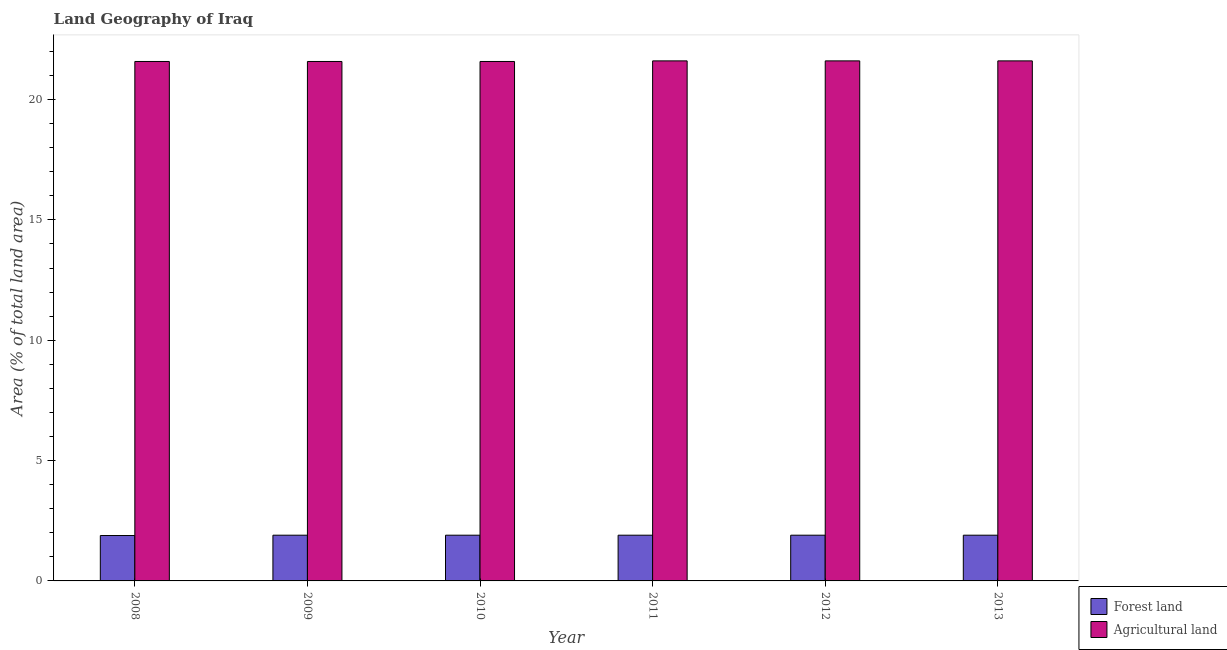Are the number of bars per tick equal to the number of legend labels?
Offer a very short reply. Yes. How many bars are there on the 5th tick from the right?
Ensure brevity in your answer.  2. In how many cases, is the number of bars for a given year not equal to the number of legend labels?
Ensure brevity in your answer.  0. What is the percentage of land area under forests in 2011?
Offer a terse response. 1.9. Across all years, what is the maximum percentage of land area under forests?
Make the answer very short. 1.9. Across all years, what is the minimum percentage of land area under forests?
Keep it short and to the point. 1.89. In which year was the percentage of land area under forests maximum?
Your response must be concise. 2009. In which year was the percentage of land area under agriculture minimum?
Your response must be concise. 2008. What is the total percentage of land area under agriculture in the graph?
Your response must be concise. 129.56. What is the difference between the percentage of land area under agriculture in 2008 and that in 2011?
Keep it short and to the point. -0.03. What is the average percentage of land area under forests per year?
Keep it short and to the point. 1.9. In how many years, is the percentage of land area under forests greater than 13 %?
Provide a short and direct response. 0. Is the percentage of land area under agriculture in 2012 less than that in 2013?
Provide a succinct answer. No. Is the difference between the percentage of land area under forests in 2008 and 2013 greater than the difference between the percentage of land area under agriculture in 2008 and 2013?
Offer a very short reply. No. What is the difference between the highest and the lowest percentage of land area under forests?
Provide a short and direct response. 0.01. In how many years, is the percentage of land area under forests greater than the average percentage of land area under forests taken over all years?
Keep it short and to the point. 5. What does the 2nd bar from the left in 2009 represents?
Make the answer very short. Agricultural land. What does the 1st bar from the right in 2011 represents?
Your answer should be very brief. Agricultural land. Are all the bars in the graph horizontal?
Your response must be concise. No. What is the difference between two consecutive major ticks on the Y-axis?
Your response must be concise. 5. Are the values on the major ticks of Y-axis written in scientific E-notation?
Keep it short and to the point. No. Does the graph contain any zero values?
Your answer should be compact. No. Does the graph contain grids?
Keep it short and to the point. No. What is the title of the graph?
Your answer should be compact. Land Geography of Iraq. What is the label or title of the Y-axis?
Keep it short and to the point. Area (% of total land area). What is the Area (% of total land area) of Forest land in 2008?
Offer a very short reply. 1.89. What is the Area (% of total land area) in Agricultural land in 2008?
Your answer should be very brief. 21.58. What is the Area (% of total land area) in Forest land in 2009?
Your answer should be very brief. 1.9. What is the Area (% of total land area) in Agricultural land in 2009?
Give a very brief answer. 21.58. What is the Area (% of total land area) of Forest land in 2010?
Provide a short and direct response. 1.9. What is the Area (% of total land area) in Agricultural land in 2010?
Provide a succinct answer. 21.58. What is the Area (% of total land area) in Forest land in 2011?
Keep it short and to the point. 1.9. What is the Area (% of total land area) in Agricultural land in 2011?
Provide a succinct answer. 21.61. What is the Area (% of total land area) in Forest land in 2012?
Provide a short and direct response. 1.9. What is the Area (% of total land area) in Agricultural land in 2012?
Your response must be concise. 21.61. What is the Area (% of total land area) in Forest land in 2013?
Give a very brief answer. 1.9. What is the Area (% of total land area) in Agricultural land in 2013?
Make the answer very short. 21.61. Across all years, what is the maximum Area (% of total land area) of Forest land?
Give a very brief answer. 1.9. Across all years, what is the maximum Area (% of total land area) in Agricultural land?
Your response must be concise. 21.61. Across all years, what is the minimum Area (% of total land area) of Forest land?
Your answer should be compact. 1.89. Across all years, what is the minimum Area (% of total land area) of Agricultural land?
Give a very brief answer. 21.58. What is the total Area (% of total land area) of Forest land in the graph?
Provide a short and direct response. 11.38. What is the total Area (% of total land area) of Agricultural land in the graph?
Offer a very short reply. 129.56. What is the difference between the Area (% of total land area) in Forest land in 2008 and that in 2009?
Provide a short and direct response. -0.01. What is the difference between the Area (% of total land area) in Forest land in 2008 and that in 2010?
Your response must be concise. -0.01. What is the difference between the Area (% of total land area) in Forest land in 2008 and that in 2011?
Your answer should be very brief. -0.01. What is the difference between the Area (% of total land area) in Agricultural land in 2008 and that in 2011?
Provide a succinct answer. -0.03. What is the difference between the Area (% of total land area) in Forest land in 2008 and that in 2012?
Provide a succinct answer. -0.01. What is the difference between the Area (% of total land area) in Agricultural land in 2008 and that in 2012?
Keep it short and to the point. -0.03. What is the difference between the Area (% of total land area) in Forest land in 2008 and that in 2013?
Make the answer very short. -0.01. What is the difference between the Area (% of total land area) in Agricultural land in 2008 and that in 2013?
Offer a terse response. -0.03. What is the difference between the Area (% of total land area) in Forest land in 2009 and that in 2011?
Provide a short and direct response. 0. What is the difference between the Area (% of total land area) of Agricultural land in 2009 and that in 2011?
Offer a very short reply. -0.03. What is the difference between the Area (% of total land area) of Forest land in 2009 and that in 2012?
Ensure brevity in your answer.  0. What is the difference between the Area (% of total land area) in Agricultural land in 2009 and that in 2012?
Your answer should be compact. -0.03. What is the difference between the Area (% of total land area) of Forest land in 2009 and that in 2013?
Provide a short and direct response. 0. What is the difference between the Area (% of total land area) in Agricultural land in 2009 and that in 2013?
Your answer should be very brief. -0.03. What is the difference between the Area (% of total land area) in Agricultural land in 2010 and that in 2011?
Keep it short and to the point. -0.03. What is the difference between the Area (% of total land area) of Agricultural land in 2010 and that in 2012?
Ensure brevity in your answer.  -0.03. What is the difference between the Area (% of total land area) in Forest land in 2010 and that in 2013?
Give a very brief answer. 0. What is the difference between the Area (% of total land area) of Agricultural land in 2010 and that in 2013?
Offer a terse response. -0.03. What is the difference between the Area (% of total land area) in Forest land in 2011 and that in 2012?
Your answer should be compact. 0. What is the difference between the Area (% of total land area) in Agricultural land in 2011 and that in 2012?
Your answer should be compact. 0. What is the difference between the Area (% of total land area) in Forest land in 2011 and that in 2013?
Offer a very short reply. 0. What is the difference between the Area (% of total land area) in Agricultural land in 2011 and that in 2013?
Offer a very short reply. 0. What is the difference between the Area (% of total land area) in Forest land in 2012 and that in 2013?
Offer a terse response. 0. What is the difference between the Area (% of total land area) of Forest land in 2008 and the Area (% of total land area) of Agricultural land in 2009?
Offer a very short reply. -19.7. What is the difference between the Area (% of total land area) of Forest land in 2008 and the Area (% of total land area) of Agricultural land in 2010?
Your answer should be very brief. -19.7. What is the difference between the Area (% of total land area) in Forest land in 2008 and the Area (% of total land area) in Agricultural land in 2011?
Your answer should be compact. -19.72. What is the difference between the Area (% of total land area) in Forest land in 2008 and the Area (% of total land area) in Agricultural land in 2012?
Provide a short and direct response. -19.72. What is the difference between the Area (% of total land area) in Forest land in 2008 and the Area (% of total land area) in Agricultural land in 2013?
Ensure brevity in your answer.  -19.72. What is the difference between the Area (% of total land area) of Forest land in 2009 and the Area (% of total land area) of Agricultural land in 2010?
Your response must be concise. -19.68. What is the difference between the Area (% of total land area) of Forest land in 2009 and the Area (% of total land area) of Agricultural land in 2011?
Your answer should be very brief. -19.71. What is the difference between the Area (% of total land area) in Forest land in 2009 and the Area (% of total land area) in Agricultural land in 2012?
Provide a succinct answer. -19.71. What is the difference between the Area (% of total land area) in Forest land in 2009 and the Area (% of total land area) in Agricultural land in 2013?
Offer a very short reply. -19.71. What is the difference between the Area (% of total land area) in Forest land in 2010 and the Area (% of total land area) in Agricultural land in 2011?
Ensure brevity in your answer.  -19.71. What is the difference between the Area (% of total land area) of Forest land in 2010 and the Area (% of total land area) of Agricultural land in 2012?
Your answer should be compact. -19.71. What is the difference between the Area (% of total land area) in Forest land in 2010 and the Area (% of total land area) in Agricultural land in 2013?
Offer a terse response. -19.71. What is the difference between the Area (% of total land area) in Forest land in 2011 and the Area (% of total land area) in Agricultural land in 2012?
Give a very brief answer. -19.71. What is the difference between the Area (% of total land area) in Forest land in 2011 and the Area (% of total land area) in Agricultural land in 2013?
Give a very brief answer. -19.71. What is the difference between the Area (% of total land area) of Forest land in 2012 and the Area (% of total land area) of Agricultural land in 2013?
Keep it short and to the point. -19.71. What is the average Area (% of total land area) in Forest land per year?
Provide a short and direct response. 1.9. What is the average Area (% of total land area) in Agricultural land per year?
Your answer should be very brief. 21.59. In the year 2008, what is the difference between the Area (% of total land area) in Forest land and Area (% of total land area) in Agricultural land?
Provide a short and direct response. -19.7. In the year 2009, what is the difference between the Area (% of total land area) in Forest land and Area (% of total land area) in Agricultural land?
Offer a very short reply. -19.68. In the year 2010, what is the difference between the Area (% of total land area) in Forest land and Area (% of total land area) in Agricultural land?
Provide a short and direct response. -19.68. In the year 2011, what is the difference between the Area (% of total land area) of Forest land and Area (% of total land area) of Agricultural land?
Keep it short and to the point. -19.71. In the year 2012, what is the difference between the Area (% of total land area) in Forest land and Area (% of total land area) in Agricultural land?
Provide a short and direct response. -19.71. In the year 2013, what is the difference between the Area (% of total land area) in Forest land and Area (% of total land area) in Agricultural land?
Ensure brevity in your answer.  -19.71. What is the ratio of the Area (% of total land area) of Agricultural land in 2008 to that in 2009?
Make the answer very short. 1. What is the ratio of the Area (% of total land area) of Forest land in 2008 to that in 2011?
Your answer should be compact. 0.99. What is the ratio of the Area (% of total land area) in Forest land in 2008 to that in 2012?
Your response must be concise. 0.99. What is the ratio of the Area (% of total land area) of Agricultural land in 2008 to that in 2012?
Provide a succinct answer. 1. What is the ratio of the Area (% of total land area) of Forest land in 2008 to that in 2013?
Keep it short and to the point. 0.99. What is the ratio of the Area (% of total land area) of Forest land in 2009 to that in 2010?
Offer a very short reply. 1. What is the ratio of the Area (% of total land area) of Forest land in 2009 to that in 2011?
Your answer should be compact. 1. What is the ratio of the Area (% of total land area) of Forest land in 2009 to that in 2012?
Offer a terse response. 1. What is the ratio of the Area (% of total land area) of Forest land in 2009 to that in 2013?
Your answer should be compact. 1. What is the ratio of the Area (% of total land area) of Forest land in 2010 to that in 2011?
Your answer should be compact. 1. What is the ratio of the Area (% of total land area) of Forest land in 2010 to that in 2012?
Make the answer very short. 1. What is the ratio of the Area (% of total land area) in Agricultural land in 2010 to that in 2012?
Give a very brief answer. 1. What is the ratio of the Area (% of total land area) of Forest land in 2010 to that in 2013?
Offer a very short reply. 1. What is the ratio of the Area (% of total land area) in Agricultural land in 2010 to that in 2013?
Ensure brevity in your answer.  1. What is the ratio of the Area (% of total land area) in Forest land in 2011 to that in 2012?
Your answer should be compact. 1. What is the ratio of the Area (% of total land area) in Agricultural land in 2011 to that in 2012?
Ensure brevity in your answer.  1. What is the ratio of the Area (% of total land area) of Forest land in 2011 to that in 2013?
Keep it short and to the point. 1. What is the ratio of the Area (% of total land area) in Agricultural land in 2012 to that in 2013?
Your answer should be very brief. 1. What is the difference between the highest and the second highest Area (% of total land area) in Forest land?
Your answer should be very brief. 0. What is the difference between the highest and the second highest Area (% of total land area) of Agricultural land?
Offer a very short reply. 0. What is the difference between the highest and the lowest Area (% of total land area) in Forest land?
Give a very brief answer. 0.01. What is the difference between the highest and the lowest Area (% of total land area) in Agricultural land?
Provide a short and direct response. 0.03. 